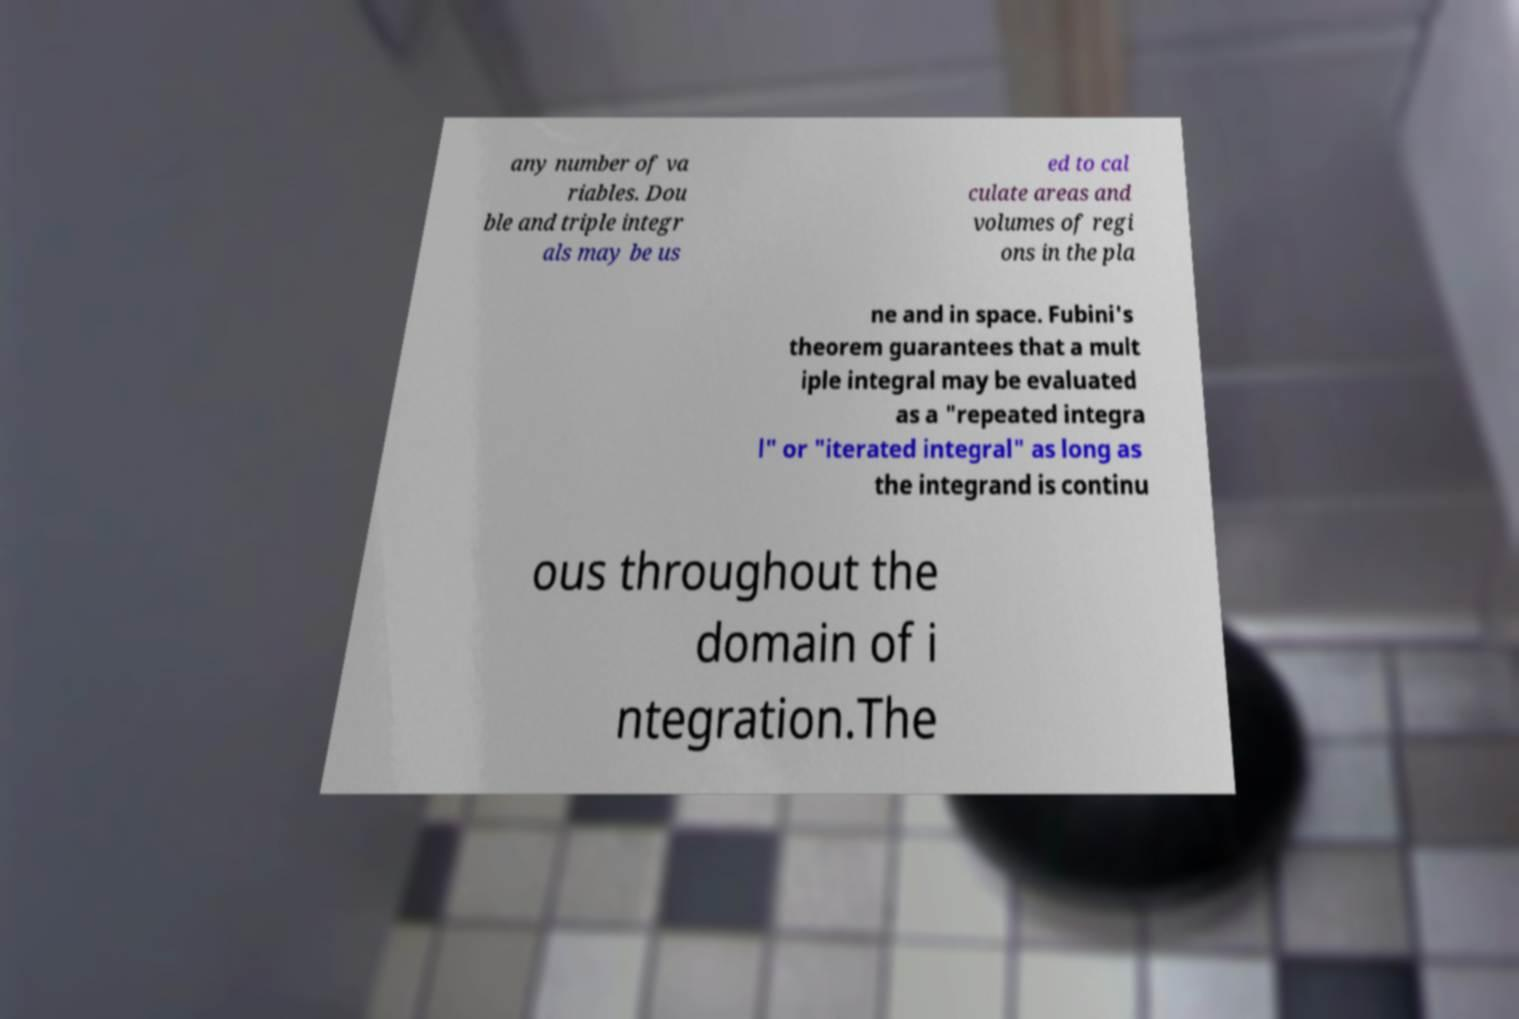What messages or text are displayed in this image? I need them in a readable, typed format. any number of va riables. Dou ble and triple integr als may be us ed to cal culate areas and volumes of regi ons in the pla ne and in space. Fubini's theorem guarantees that a mult iple integral may be evaluated as a "repeated integra l" or "iterated integral" as long as the integrand is continu ous throughout the domain of i ntegration.The 